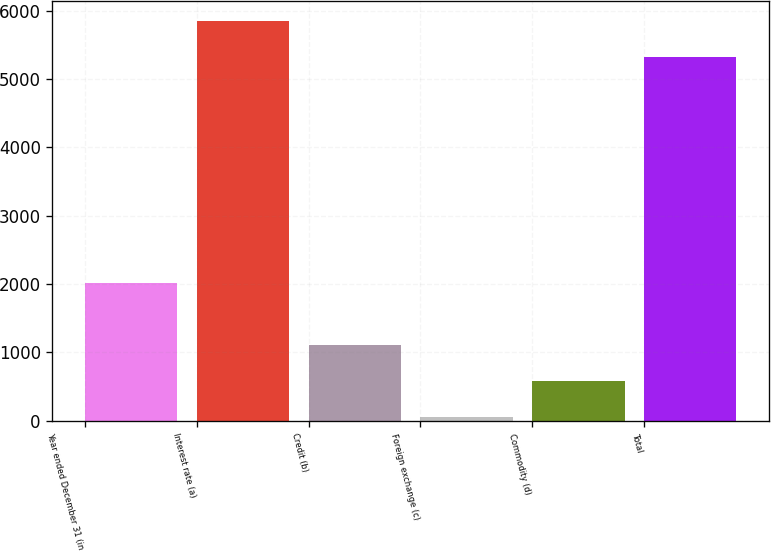<chart> <loc_0><loc_0><loc_500><loc_500><bar_chart><fcel>Year ended December 31 (in<fcel>Interest rate (a)<fcel>Credit (b)<fcel>Foreign exchange (c)<fcel>Commodity (d)<fcel>Total<nl><fcel>2012<fcel>5849.6<fcel>1108.2<fcel>47<fcel>577.6<fcel>5319<nl></chart> 